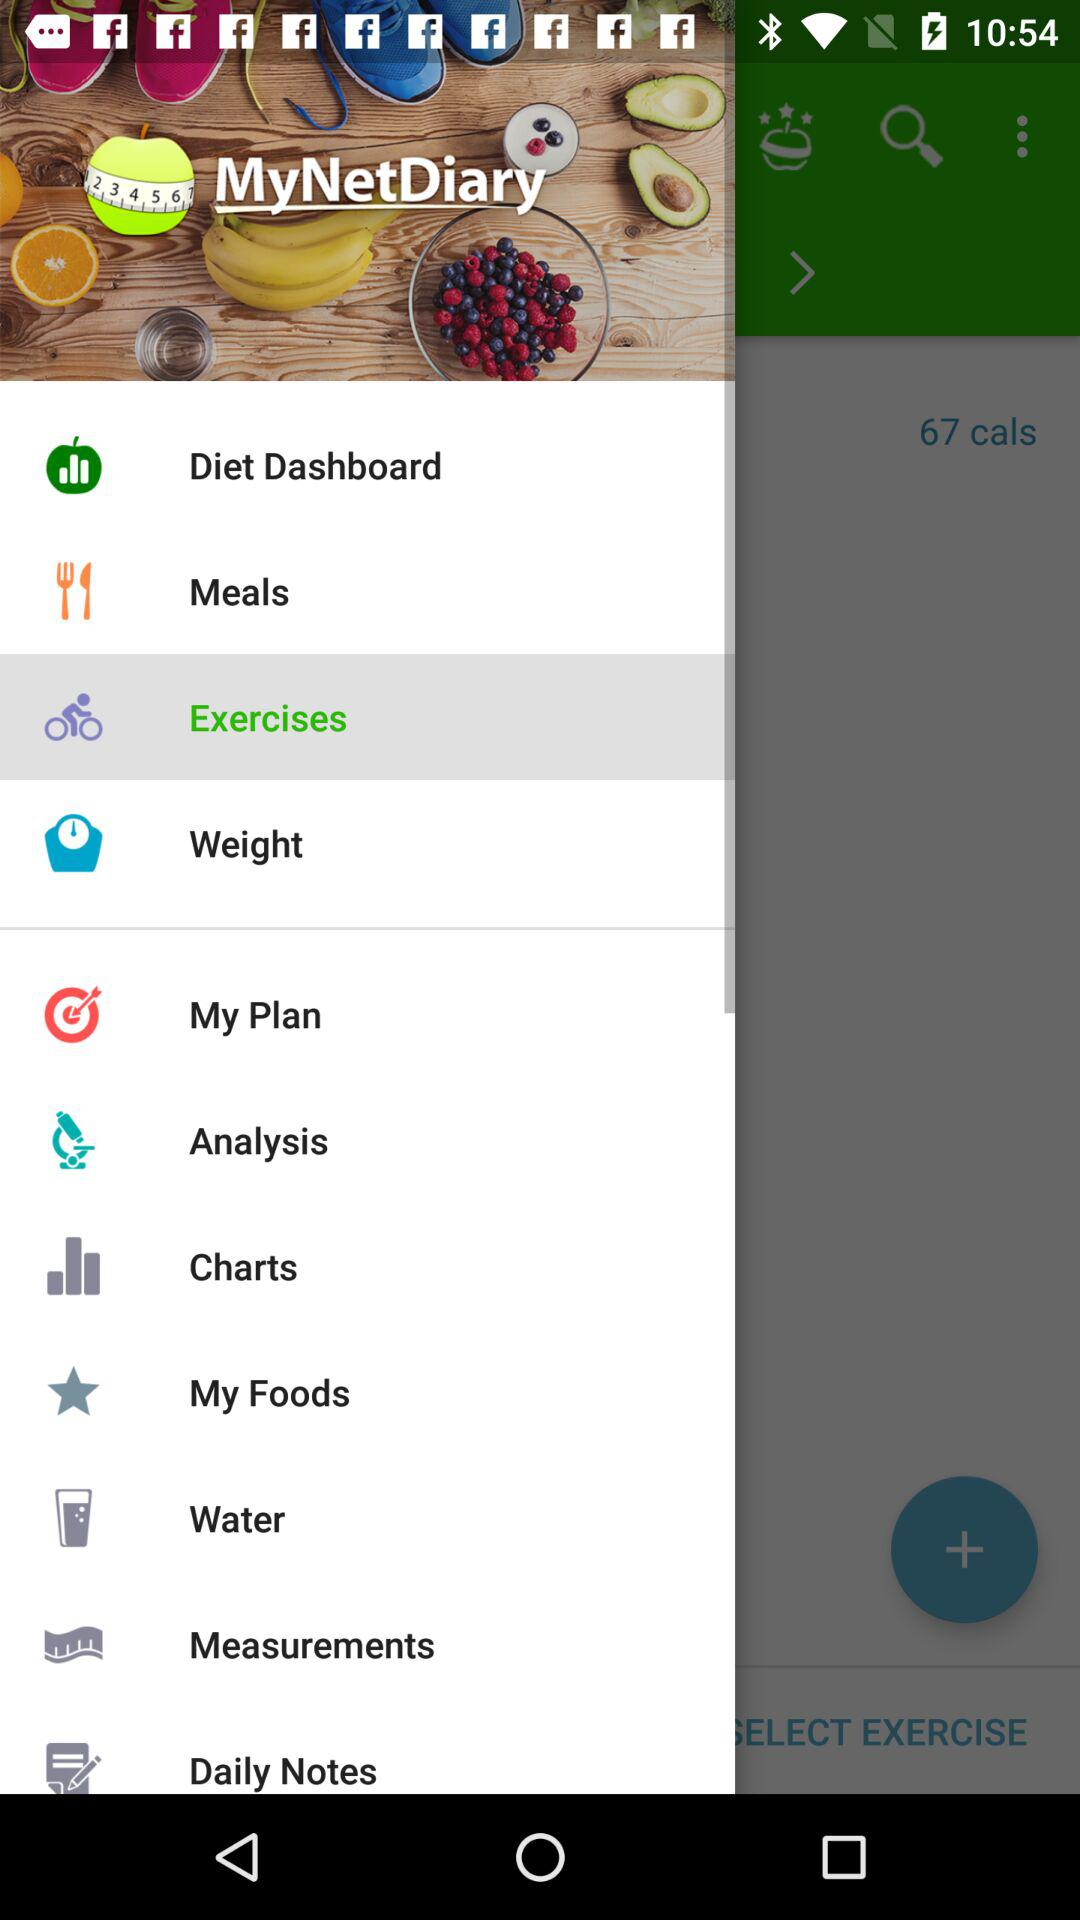Which option is selected? The selected option is "Exercises". 